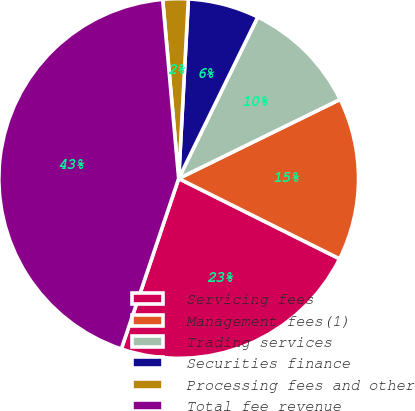Convert chart to OTSL. <chart><loc_0><loc_0><loc_500><loc_500><pie_chart><fcel>Servicing fees<fcel>Management fees(1)<fcel>Trading services<fcel>Securities finance<fcel>Processing fees and other<fcel>Total fee revenue<nl><fcel>22.8%<fcel>14.62%<fcel>10.5%<fcel>6.39%<fcel>2.28%<fcel>43.41%<nl></chart> 